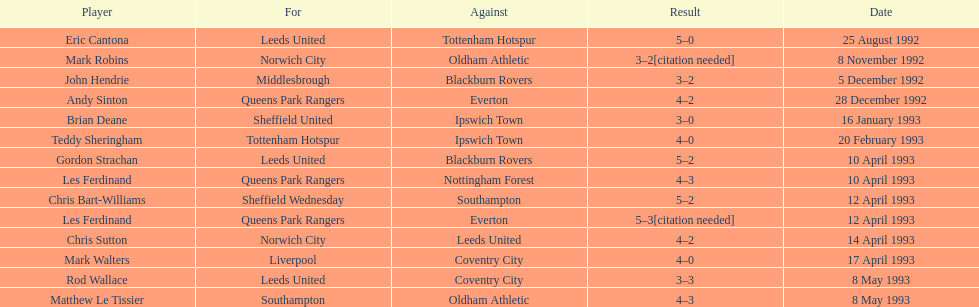In the 1992-1993 premier league, what was the total number of hat tricks scored by all players? 14. 